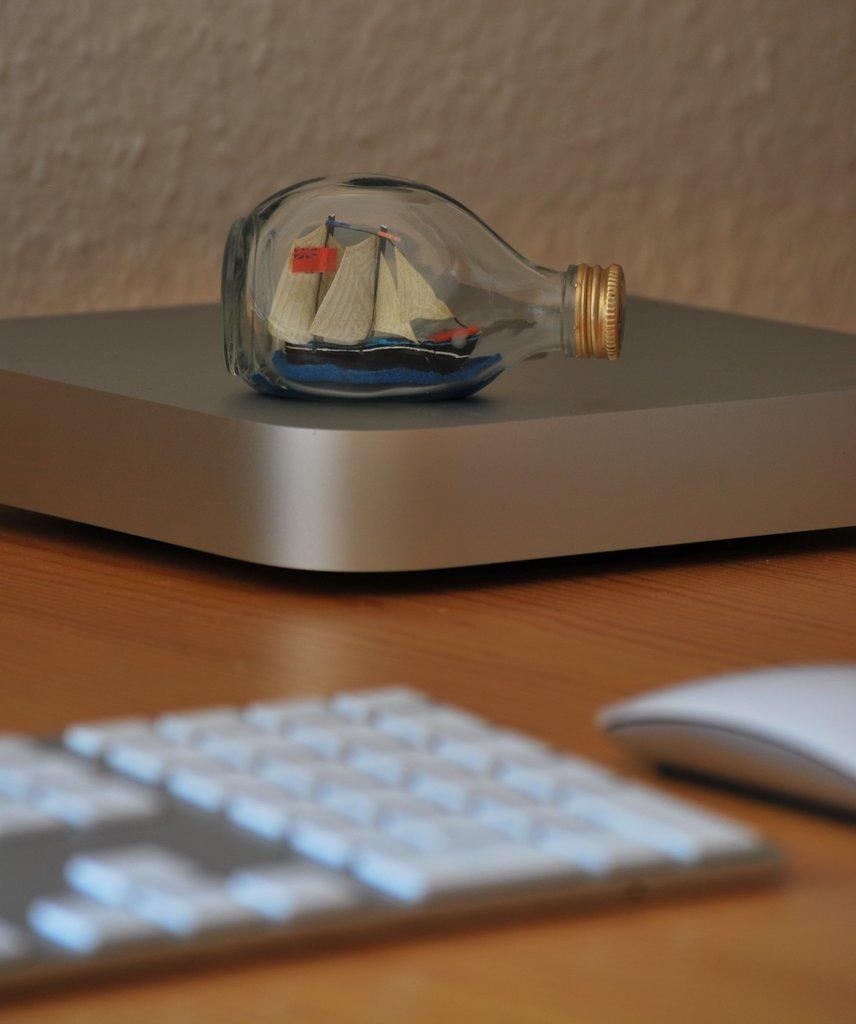Can you describe this image briefly? In this image there is a bottle and a keyboard which is on the table. In the background there is a wall. 